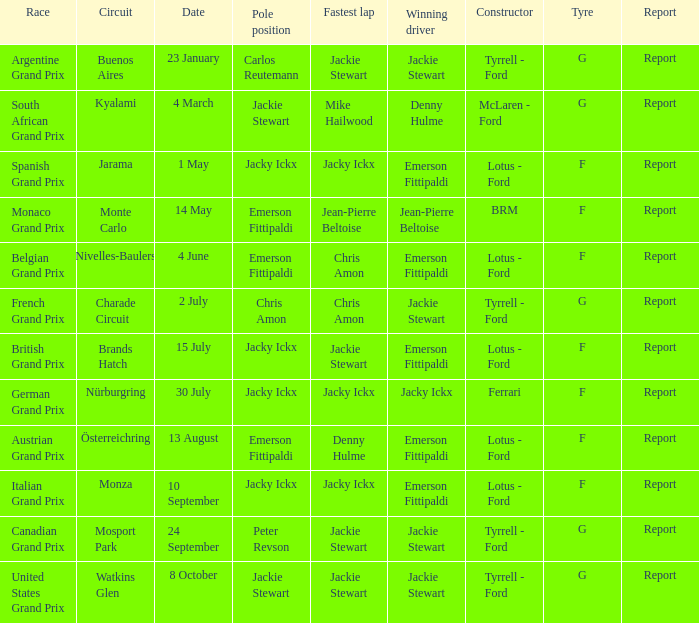When did the Argentine Grand Prix race? 23 January. 